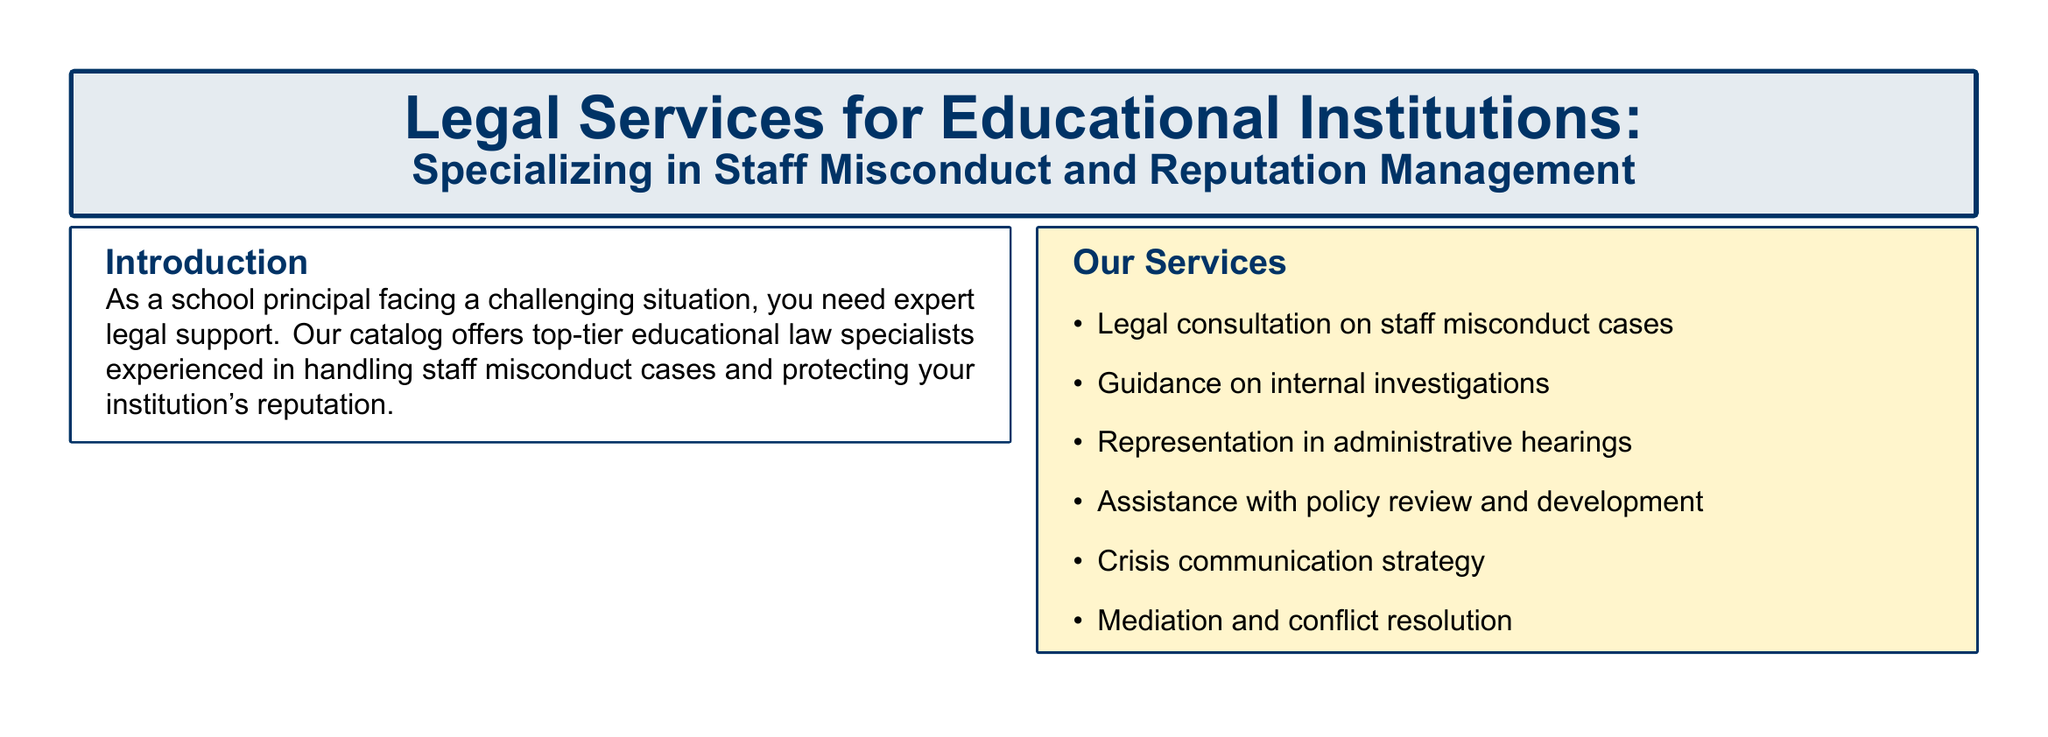What is the title of the document? The title of the document is displayed at the top, introducing the subject matter.
Answer: Legal Services for Educational Institutions: Specializing in Staff Misconduct and Reputation Management What is the contact number for Edlaw Partners LLP? The contact number for Edlaw Partners LLP is listed under the firm's details in the document.
Answer: (555) 123-4567 What is one of the services offered? One of the services is mentioned in a bulleted list describing their expertise and offerings.
Answer: Legal consultation on staff misconduct cases Who is the individual attorney specializing in educational employment law? The document lists individual attorneys and their specializations; this question pertains to one of them.
Answer: Sarah J. Thompson, Esq What is the testimonial about? The testimonial reflects on the experience of a client regarding the legal support provided.
Answer: Navigating the complexities of staff misconduct while preserving our institution's reputation What type of law do the specialized legal services focus on? The document specifies the area of focus for legal services mentioned in the introduction.
Answer: Educational law What is the email contact for Michael R. Davis? The document includes contact information for individual attorneys, including their emails.
Answer: mdavis@schoollawconsultants.com What is the main purpose of this catalog? The introduction summarizes the intent of the catalog for the reader.
Answer: Expert legal support for educational institutions facing staff misconduct cases 